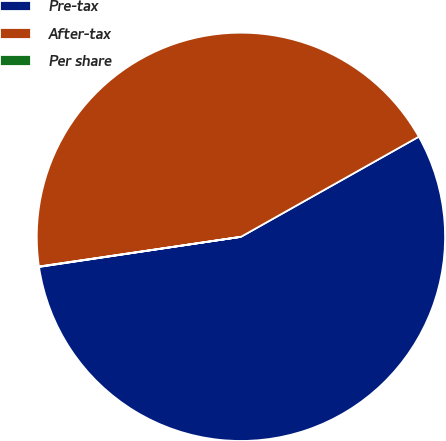Convert chart. <chart><loc_0><loc_0><loc_500><loc_500><pie_chart><fcel>Pre-tax<fcel>After-tax<fcel>Per share<nl><fcel>55.81%<fcel>44.17%<fcel>0.03%<nl></chart> 